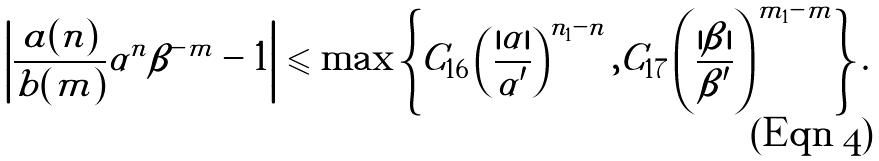<formula> <loc_0><loc_0><loc_500><loc_500>\left | \frac { a ( n ) } { b ( m ) } \alpha ^ { n } \beta ^ { - m } - 1 \right | & \leqslant \max \left \{ C _ { 1 6 } \left ( \frac { | \alpha | } { \alpha ^ { \prime } } \right ) ^ { n _ { 1 } - n } , C _ { 1 7 } \left ( \frac { | \beta | } { \beta ^ { \prime } } \right ) ^ { m _ { 1 } - m } \right \} .</formula> 